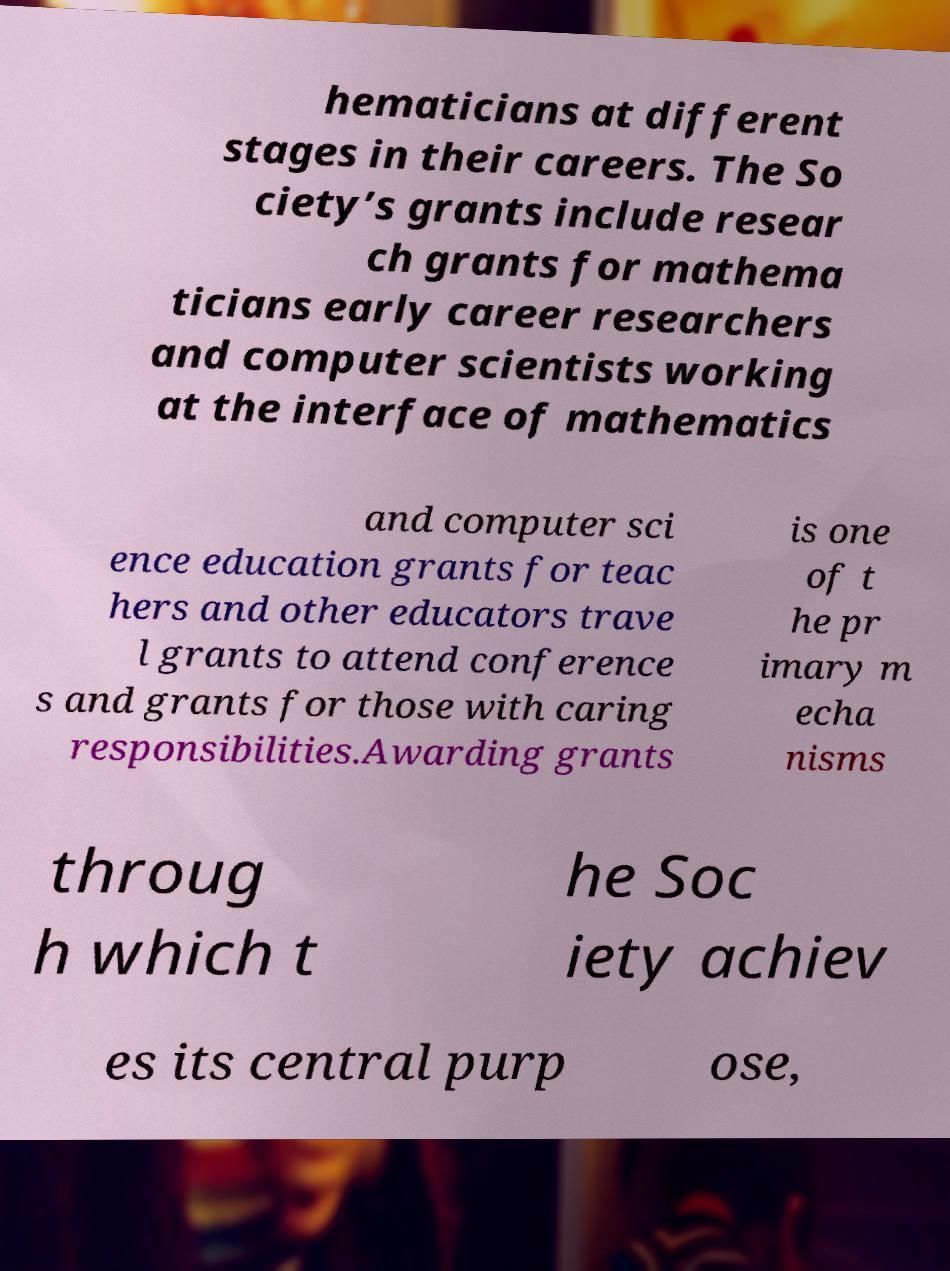Could you assist in decoding the text presented in this image and type it out clearly? hematicians at different stages in their careers. The So ciety’s grants include resear ch grants for mathema ticians early career researchers and computer scientists working at the interface of mathematics and computer sci ence education grants for teac hers and other educators trave l grants to attend conference s and grants for those with caring responsibilities.Awarding grants is one of t he pr imary m echa nisms throug h which t he Soc iety achiev es its central purp ose, 